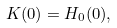Convert formula to latex. <formula><loc_0><loc_0><loc_500><loc_500>K ( 0 ) = H _ { 0 } ( 0 ) ,</formula> 